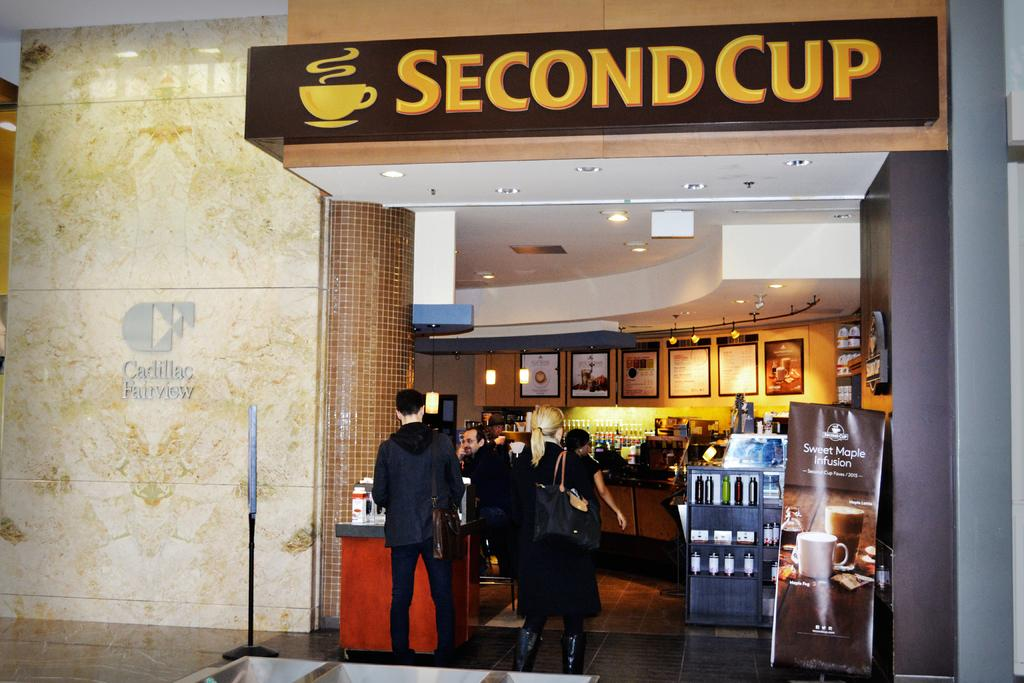<image>
Share a concise interpretation of the image provided. The front entry to the coffee shop called "second cup" is shown as two people wait around the front. 